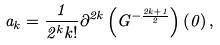Convert formula to latex. <formula><loc_0><loc_0><loc_500><loc_500>a _ { k } = \frac { 1 } { 2 ^ { k } k ! } \partial ^ { 2 k } \left ( { G ^ { - \frac { 2 k + 1 } { 2 } } } \right ) \left ( 0 \right ) ,</formula> 